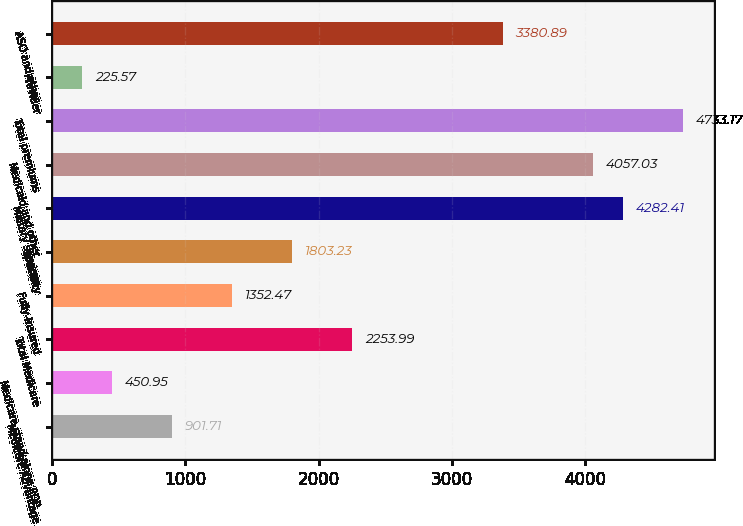<chart> <loc_0><loc_0><loc_500><loc_500><bar_chart><fcel>Medicare Advantage<fcel>Medicare stand-alone PDP<fcel>Total Medicare<fcel>Fully-insured<fcel>Specialty<fcel>Military services<fcel>Medicaid and other<fcel>Total premiums<fcel>Provider<fcel>ASO and other<nl><fcel>901.71<fcel>450.95<fcel>2253.99<fcel>1352.47<fcel>1803.23<fcel>4282.41<fcel>4057.03<fcel>4733.17<fcel>225.57<fcel>3380.89<nl></chart> 